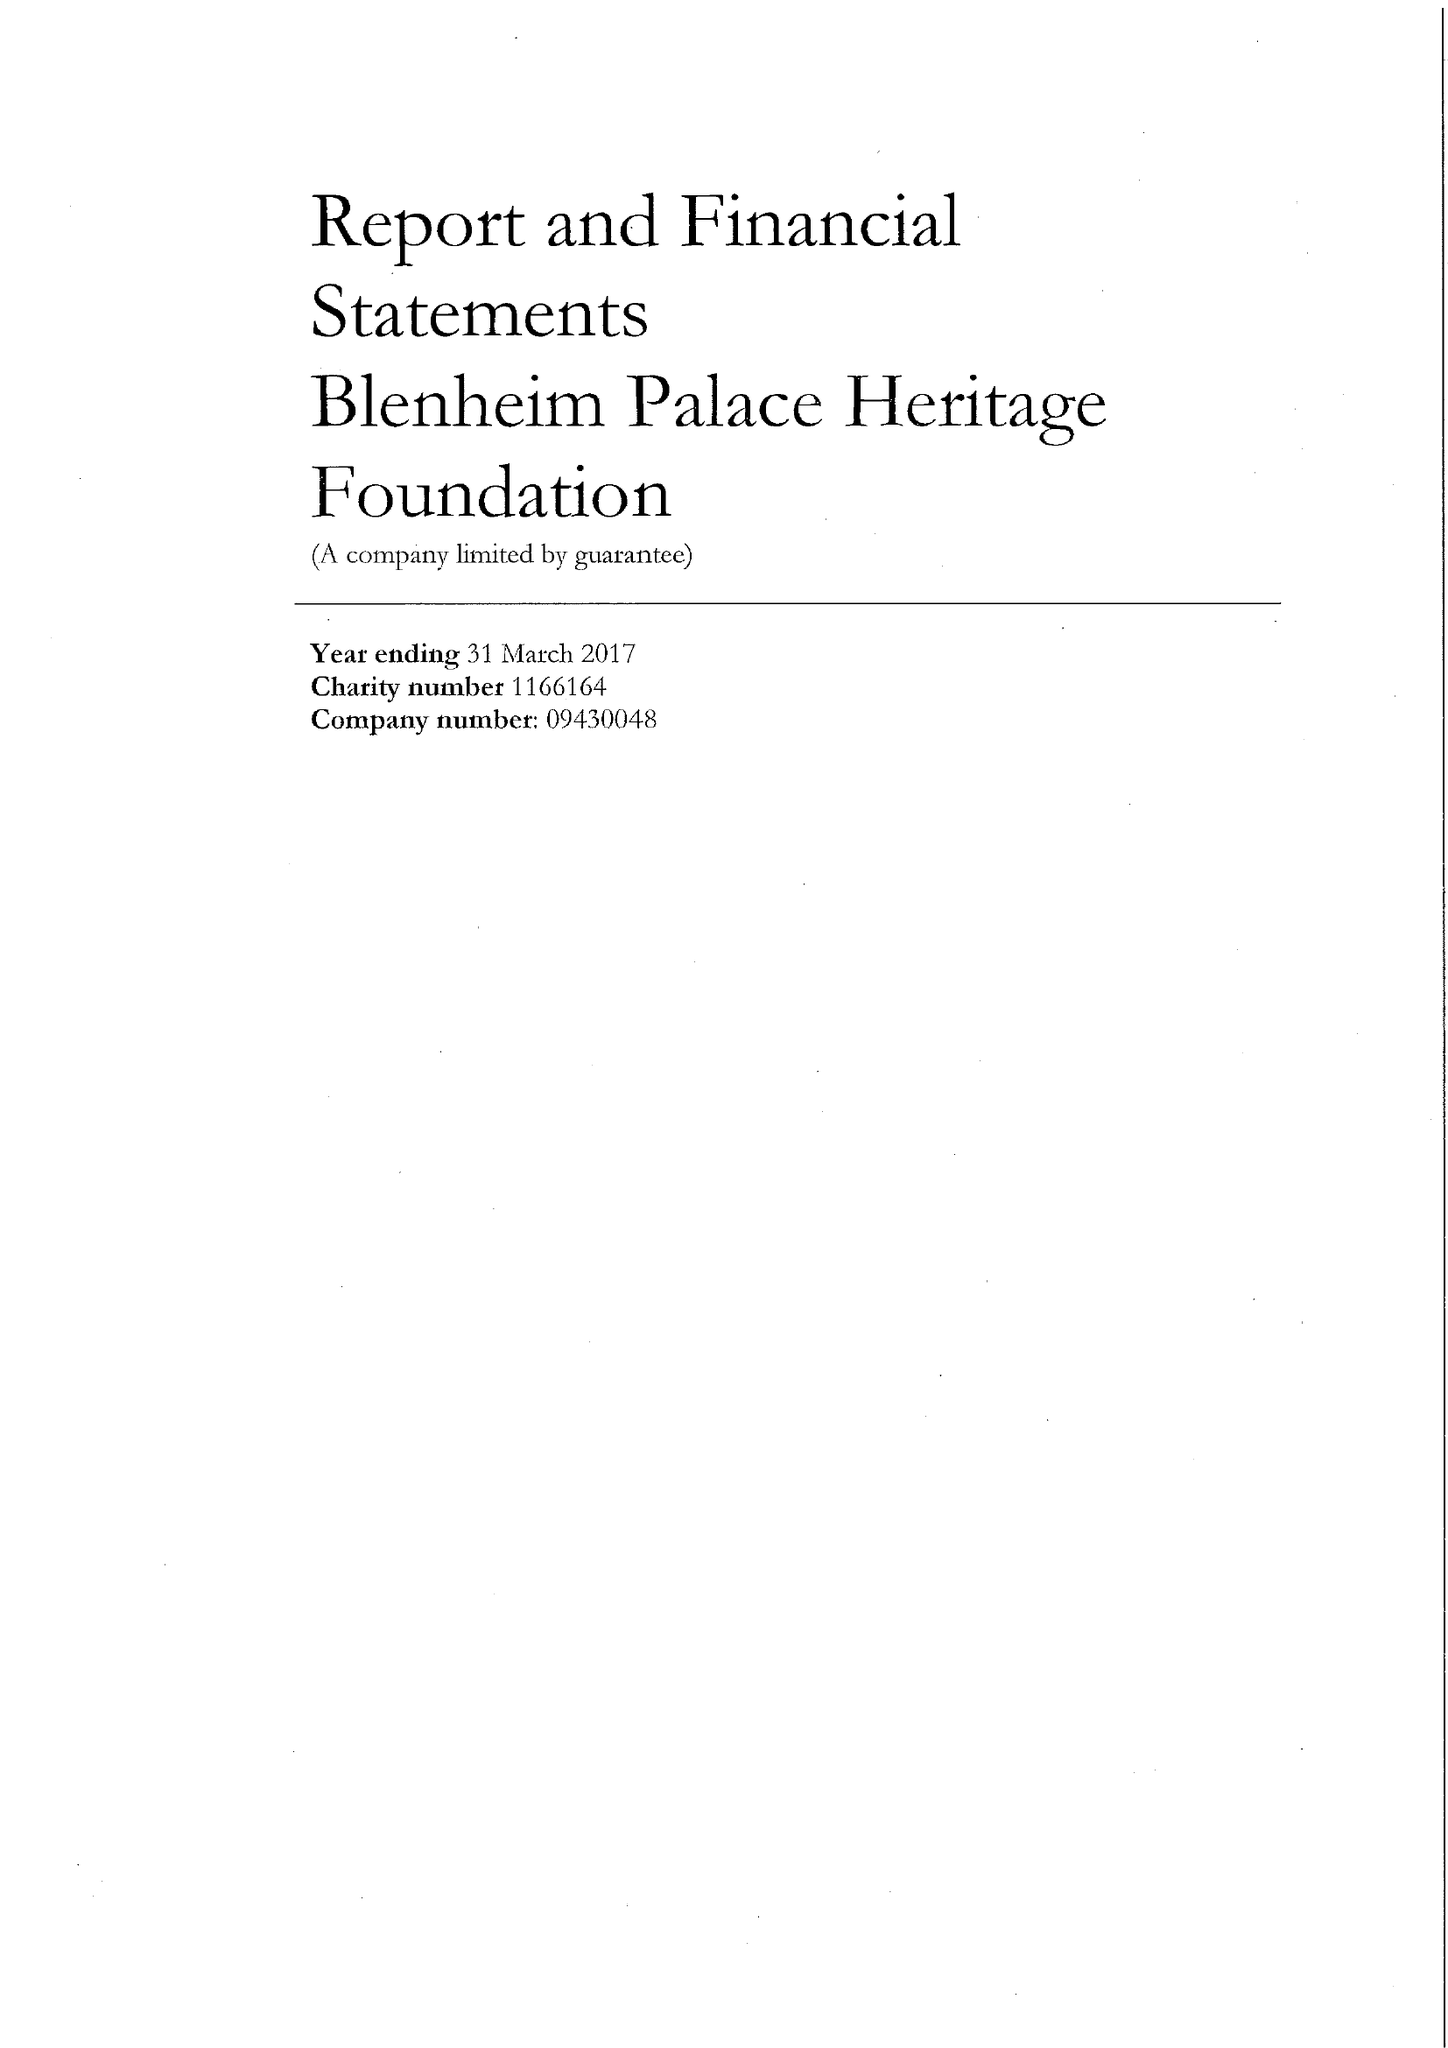What is the value for the report_date?
Answer the question using a single word or phrase. 2017-03-31 